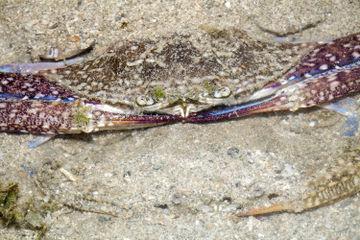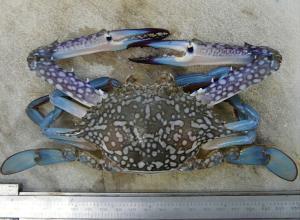The first image is the image on the left, the second image is the image on the right. Evaluate the accuracy of this statement regarding the images: "One crab is standing up tall on the sand.". Is it true? Answer yes or no. No. The first image is the image on the left, the second image is the image on the right. Assess this claim about the two images: "In at least one image there is a blue crab in the water touching sand.". Correct or not? Answer yes or no. No. 